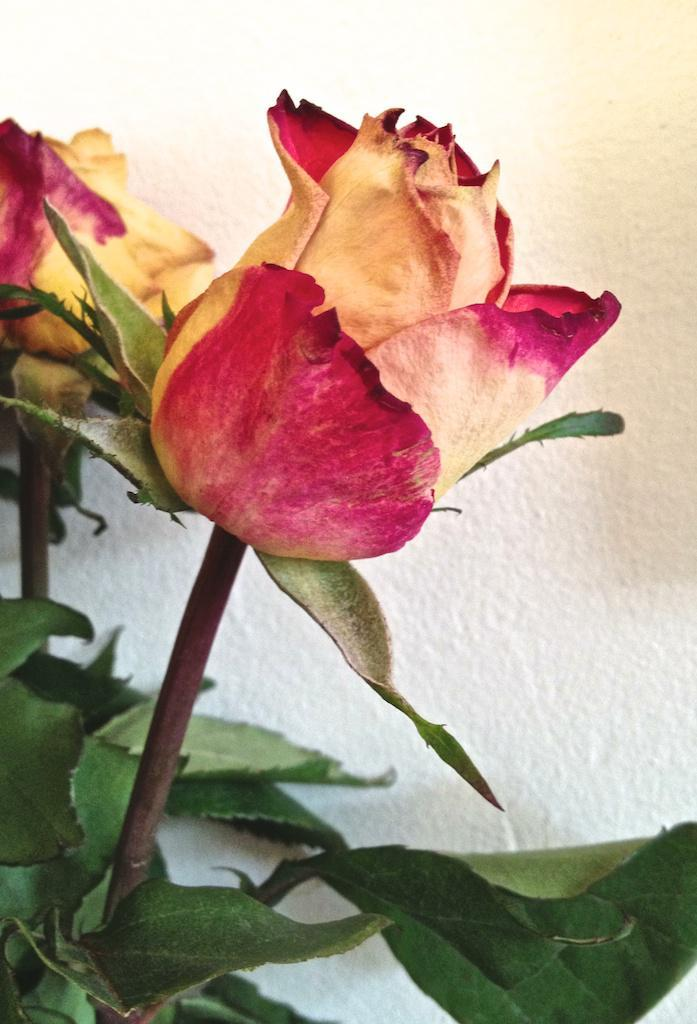What type of flowers are in the image? There are two roses in the image. What parts of the roses are visible? The roses have stems and leaves. What is the color of the background in the image? The background of the image is white. What type of government is depicted in the image? There is no government depicted in the image; it features two roses with stems and leaves against a white background. What type of tool is being used by the roses in the image? There are no tools, such as a plough, present in the image; it features two roses with stems and leaves against a white background. 